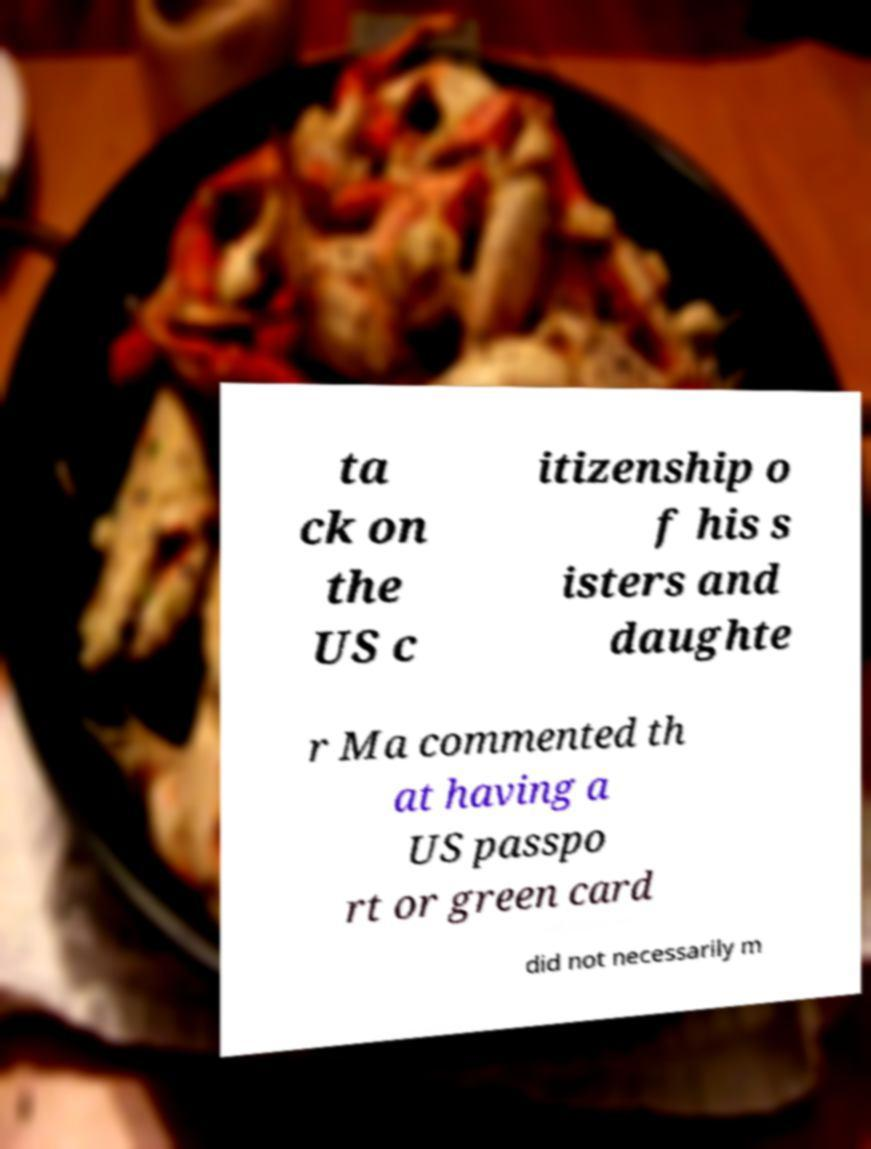What messages or text are displayed in this image? I need them in a readable, typed format. ta ck on the US c itizenship o f his s isters and daughte r Ma commented th at having a US passpo rt or green card did not necessarily m 